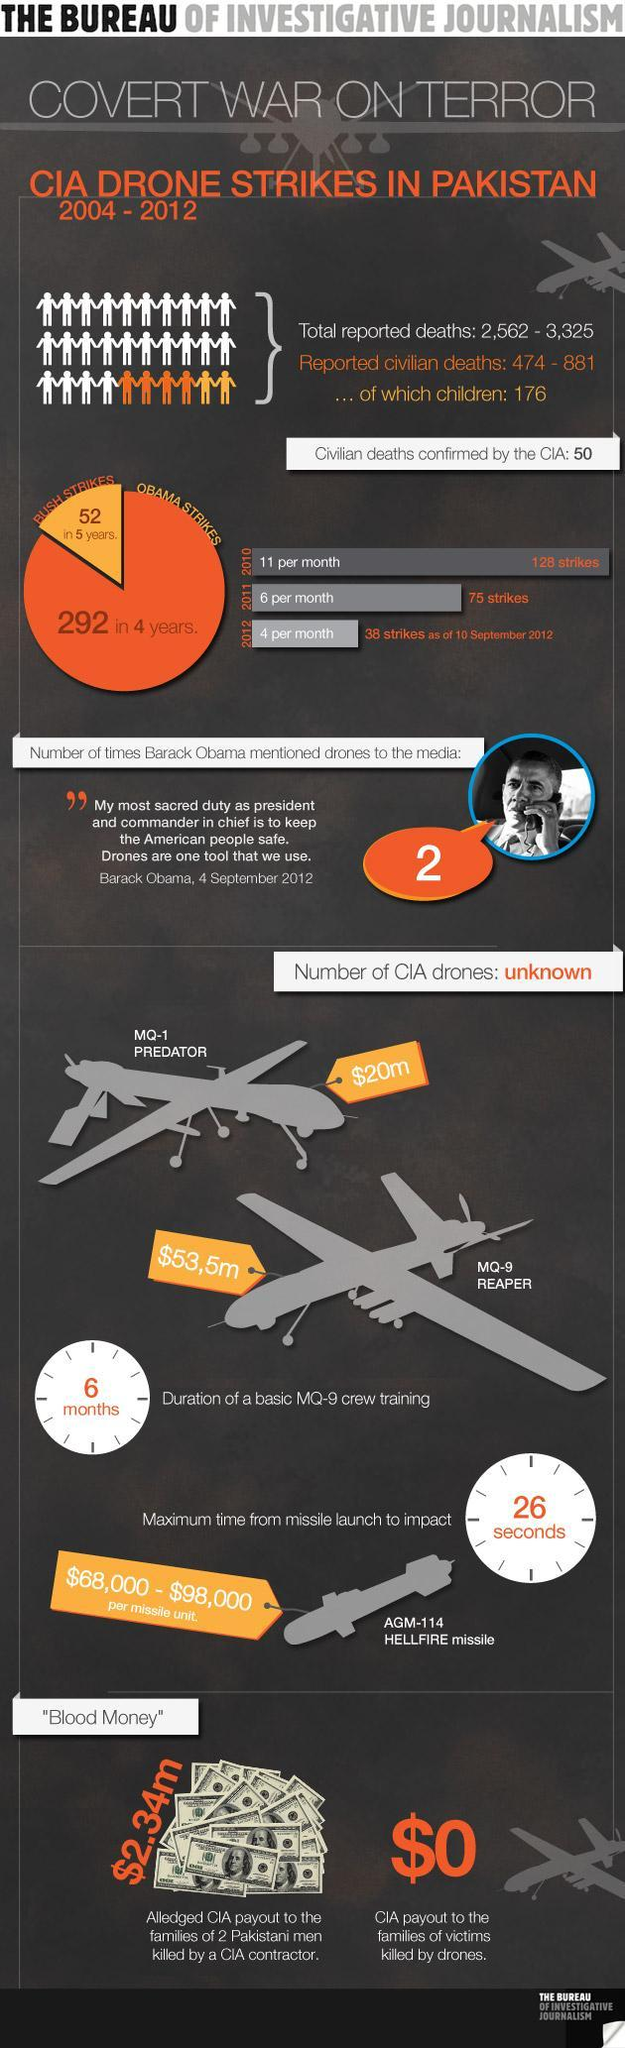How many air strikes were made per month in 2011?
Answer the question with a short phrase. 6 How many air strikes were made in 2010? 128 What is the cost of MQ-1 Predator? $20m How many times did Obama mention drones to the media? 2 How many air strikes were made in 2012? 38 What is the CIA payout to families of victims killed by drones? $0 What is the cost of MQ-9 Reaper? $53,5m What is the CIA  payout to families of 2 victims killed by a CIA contractor? $2.34 m How long does it take for training the crew for an MQ-9? 6 months What is the per unit cost of a Hellfire missile? $68,000 - $98,000 How many strikes were made under president Bush's leadership? 52 